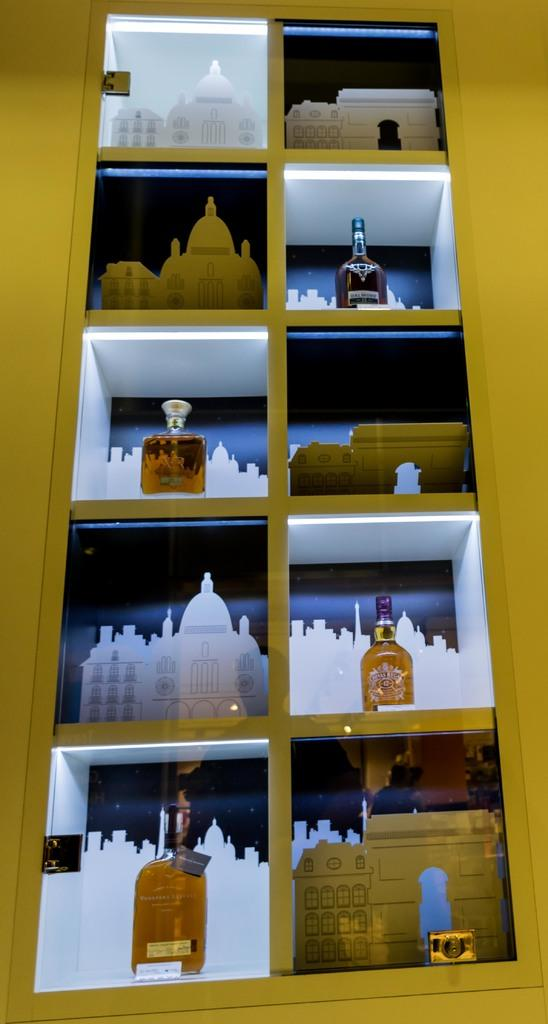What type of shelf is visible in the image? There is a glass shelf in the image. What can be seen on the glass shelf? The glass shelf contains depictions of monuments and bottles. What other object is present on the glass shelf? There is a camera on the glass shelf. Reasoning: Let' Let's think step by step in order to produce the conversation. We start by identifying the main subject in the image, which is the glass shelf. Then, we expand the conversation to include other items that are also visible on the shelf, such as the depictions of monuments, bottles, and the camera. Each question is designed to elicit a specific detail about the image that is known from the provided facts. Absurd Question/Answer: What type of honey is being produced by the steel structure in the image? There is no steel structure or honey present in the image. 